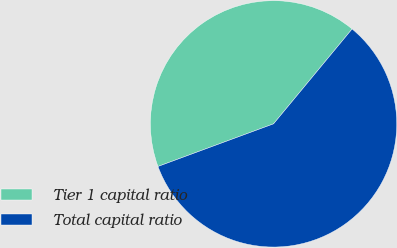<chart> <loc_0><loc_0><loc_500><loc_500><pie_chart><fcel>Tier 1 capital ratio<fcel>Total capital ratio<nl><fcel>41.63%<fcel>58.37%<nl></chart> 